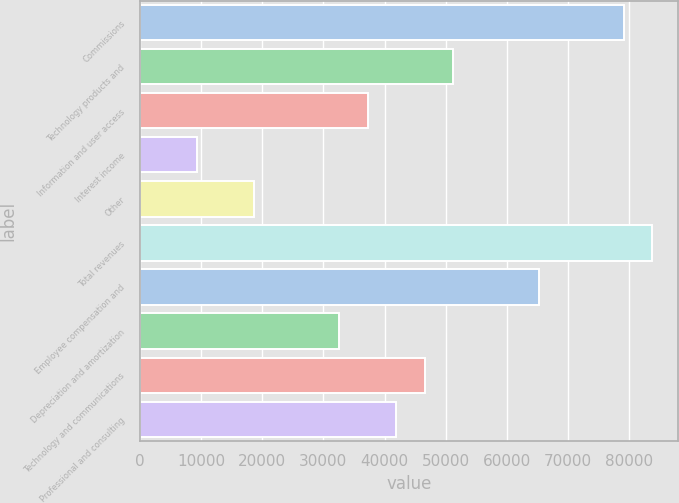Convert chart to OTSL. <chart><loc_0><loc_0><loc_500><loc_500><bar_chart><fcel>Commissions<fcel>Technology products and<fcel>Information and user access<fcel>Interest income<fcel>Other<fcel>Total revenues<fcel>Employee compensation and<fcel>Depreciation and amortization<fcel>Technology and communications<fcel>Professional and consulting<nl><fcel>79158.6<fcel>51220.4<fcel>37251.3<fcel>9313.08<fcel>18625.8<fcel>83815<fcel>65189.5<fcel>32594.9<fcel>46564<fcel>41907.7<nl></chart> 